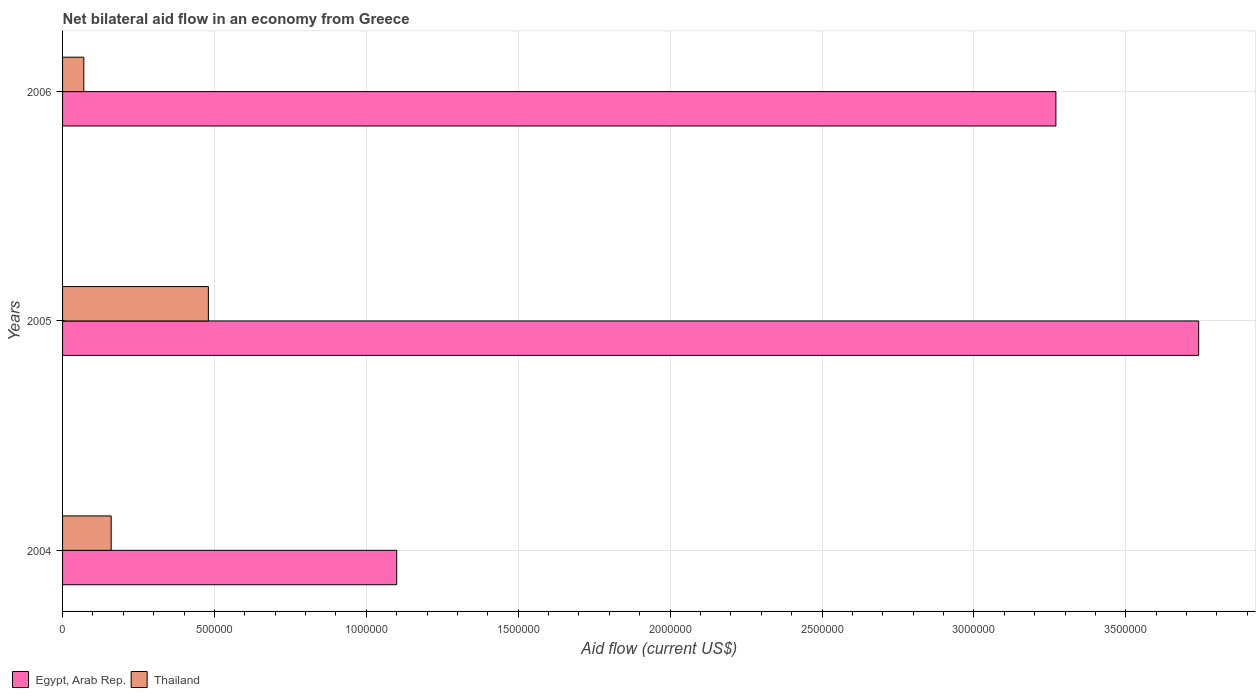How many groups of bars are there?
Keep it short and to the point. 3. Are the number of bars on each tick of the Y-axis equal?
Your answer should be very brief. Yes. How many bars are there on the 2nd tick from the top?
Keep it short and to the point. 2. How many bars are there on the 2nd tick from the bottom?
Your response must be concise. 2. What is the label of the 2nd group of bars from the top?
Make the answer very short. 2005. In how many cases, is the number of bars for a given year not equal to the number of legend labels?
Offer a terse response. 0. What is the net bilateral aid flow in Egypt, Arab Rep. in 2005?
Provide a short and direct response. 3.74e+06. Across all years, what is the maximum net bilateral aid flow in Egypt, Arab Rep.?
Provide a succinct answer. 3.74e+06. Across all years, what is the minimum net bilateral aid flow in Thailand?
Offer a very short reply. 7.00e+04. In which year was the net bilateral aid flow in Egypt, Arab Rep. maximum?
Offer a terse response. 2005. What is the total net bilateral aid flow in Thailand in the graph?
Give a very brief answer. 7.10e+05. What is the difference between the net bilateral aid flow in Egypt, Arab Rep. in 2005 and that in 2006?
Provide a succinct answer. 4.70e+05. What is the difference between the net bilateral aid flow in Egypt, Arab Rep. in 2006 and the net bilateral aid flow in Thailand in 2005?
Provide a succinct answer. 2.79e+06. What is the average net bilateral aid flow in Thailand per year?
Keep it short and to the point. 2.37e+05. In the year 2005, what is the difference between the net bilateral aid flow in Thailand and net bilateral aid flow in Egypt, Arab Rep.?
Give a very brief answer. -3.26e+06. In how many years, is the net bilateral aid flow in Egypt, Arab Rep. greater than 700000 US$?
Keep it short and to the point. 3. What is the ratio of the net bilateral aid flow in Egypt, Arab Rep. in 2004 to that in 2005?
Your answer should be compact. 0.29. What is the difference between the highest and the second highest net bilateral aid flow in Egypt, Arab Rep.?
Give a very brief answer. 4.70e+05. What is the difference between the highest and the lowest net bilateral aid flow in Thailand?
Offer a terse response. 4.10e+05. In how many years, is the net bilateral aid flow in Egypt, Arab Rep. greater than the average net bilateral aid flow in Egypt, Arab Rep. taken over all years?
Keep it short and to the point. 2. What does the 1st bar from the top in 2006 represents?
Your answer should be compact. Thailand. What does the 2nd bar from the bottom in 2005 represents?
Keep it short and to the point. Thailand. How many years are there in the graph?
Your answer should be very brief. 3. Are the values on the major ticks of X-axis written in scientific E-notation?
Your answer should be very brief. No. Does the graph contain any zero values?
Keep it short and to the point. No. Does the graph contain grids?
Make the answer very short. Yes. What is the title of the graph?
Your answer should be very brief. Net bilateral aid flow in an economy from Greece. Does "Brunei Darussalam" appear as one of the legend labels in the graph?
Your answer should be compact. No. What is the label or title of the X-axis?
Your response must be concise. Aid flow (current US$). What is the Aid flow (current US$) of Egypt, Arab Rep. in 2004?
Make the answer very short. 1.10e+06. What is the Aid flow (current US$) of Thailand in 2004?
Make the answer very short. 1.60e+05. What is the Aid flow (current US$) of Egypt, Arab Rep. in 2005?
Provide a succinct answer. 3.74e+06. What is the Aid flow (current US$) of Egypt, Arab Rep. in 2006?
Offer a terse response. 3.27e+06. What is the Aid flow (current US$) in Thailand in 2006?
Your answer should be compact. 7.00e+04. Across all years, what is the maximum Aid flow (current US$) in Egypt, Arab Rep.?
Provide a short and direct response. 3.74e+06. Across all years, what is the minimum Aid flow (current US$) in Egypt, Arab Rep.?
Keep it short and to the point. 1.10e+06. Across all years, what is the minimum Aid flow (current US$) in Thailand?
Your response must be concise. 7.00e+04. What is the total Aid flow (current US$) in Egypt, Arab Rep. in the graph?
Your response must be concise. 8.11e+06. What is the total Aid flow (current US$) in Thailand in the graph?
Your answer should be compact. 7.10e+05. What is the difference between the Aid flow (current US$) of Egypt, Arab Rep. in 2004 and that in 2005?
Your response must be concise. -2.64e+06. What is the difference between the Aid flow (current US$) in Thailand in 2004 and that in 2005?
Provide a short and direct response. -3.20e+05. What is the difference between the Aid flow (current US$) in Egypt, Arab Rep. in 2004 and that in 2006?
Ensure brevity in your answer.  -2.17e+06. What is the difference between the Aid flow (current US$) in Thailand in 2004 and that in 2006?
Keep it short and to the point. 9.00e+04. What is the difference between the Aid flow (current US$) in Thailand in 2005 and that in 2006?
Your response must be concise. 4.10e+05. What is the difference between the Aid flow (current US$) in Egypt, Arab Rep. in 2004 and the Aid flow (current US$) in Thailand in 2005?
Provide a succinct answer. 6.20e+05. What is the difference between the Aid flow (current US$) of Egypt, Arab Rep. in 2004 and the Aid flow (current US$) of Thailand in 2006?
Provide a succinct answer. 1.03e+06. What is the difference between the Aid flow (current US$) of Egypt, Arab Rep. in 2005 and the Aid flow (current US$) of Thailand in 2006?
Your answer should be compact. 3.67e+06. What is the average Aid flow (current US$) in Egypt, Arab Rep. per year?
Your answer should be very brief. 2.70e+06. What is the average Aid flow (current US$) of Thailand per year?
Provide a short and direct response. 2.37e+05. In the year 2004, what is the difference between the Aid flow (current US$) in Egypt, Arab Rep. and Aid flow (current US$) in Thailand?
Offer a very short reply. 9.40e+05. In the year 2005, what is the difference between the Aid flow (current US$) of Egypt, Arab Rep. and Aid flow (current US$) of Thailand?
Your answer should be compact. 3.26e+06. In the year 2006, what is the difference between the Aid flow (current US$) in Egypt, Arab Rep. and Aid flow (current US$) in Thailand?
Offer a very short reply. 3.20e+06. What is the ratio of the Aid flow (current US$) in Egypt, Arab Rep. in 2004 to that in 2005?
Offer a very short reply. 0.29. What is the ratio of the Aid flow (current US$) in Thailand in 2004 to that in 2005?
Keep it short and to the point. 0.33. What is the ratio of the Aid flow (current US$) in Egypt, Arab Rep. in 2004 to that in 2006?
Offer a terse response. 0.34. What is the ratio of the Aid flow (current US$) in Thailand in 2004 to that in 2006?
Your answer should be very brief. 2.29. What is the ratio of the Aid flow (current US$) of Egypt, Arab Rep. in 2005 to that in 2006?
Your response must be concise. 1.14. What is the ratio of the Aid flow (current US$) in Thailand in 2005 to that in 2006?
Make the answer very short. 6.86. What is the difference between the highest and the lowest Aid flow (current US$) in Egypt, Arab Rep.?
Keep it short and to the point. 2.64e+06. 